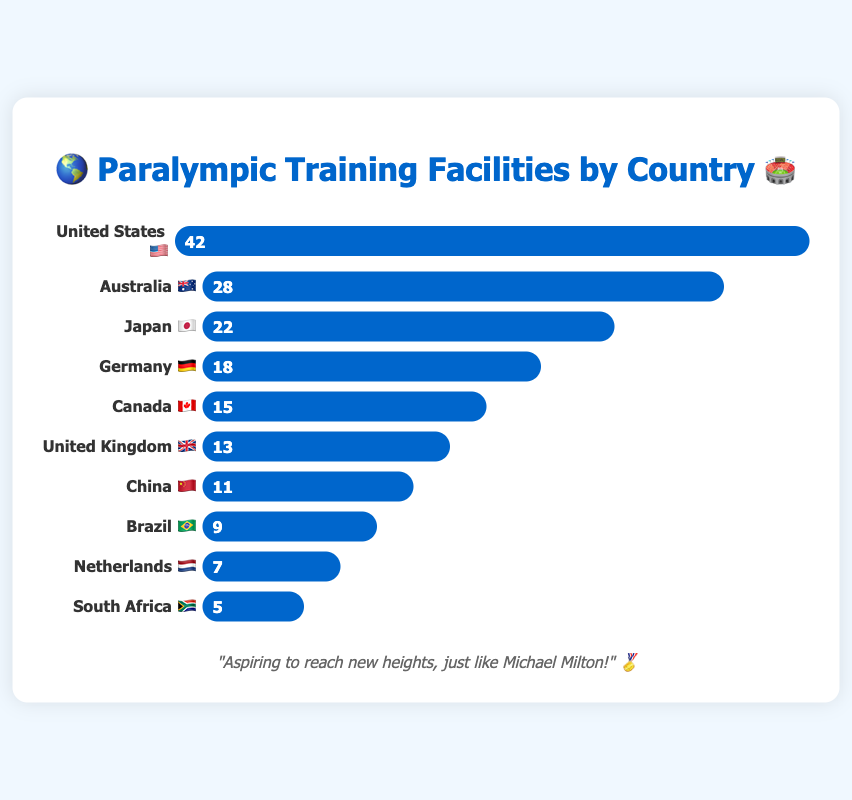What's the title of the chart? The chart title is at the top and is highlighted in blue. It reads "🌎 Paralympic Training Facilities by Country 🏟️".
Answer: 🌎 Paralympic Training Facilities by Country 🏟️ Which country has the highest number of Paralympic training facilities? The longest bar in the chart indicates the country with the most facilities. The United States 🇺🇸 has the longest bar representing 42 facilities.
Answer: United States 🇺🇸 How many facilities does Australia 🇦🇺 have? The chart shows each country with its corresponding number of facilities. Australia's bar indicates it has 28 facilities.
Answer: 28 What is the total number of Paralympic training facilities in Germany 🇩🇪 and Japan 🇯🇵 combined? Add the number of facilities in Germany (18) to those in Japan (22). This sum is 18 + 22 = 40.
Answer: 40 Which country has fewer Paralympic training facilities: Canada 🇨🇦 or the United Kingdom 🇬🇧? Compare the bars for Canada and the United Kingdom. Canada has 15 facilities, while the United Kingdom has 13. Therefore, the United Kingdom has fewer facilities.
Answer: United Kingdom 🇬🇧 What is the average number of facilities among all listed countries? There are 10 countries listed. Sum all their facilities (42 + 28 + 22 + 18 + 15 + 13 + 11 + 9 + 7 + 5 = 170) and divide this by 10. The average is 170 / 10 = 17.
Answer: 17 How many more facilities does the United States 🇺🇸 have compared to China 🇨🇳? Subtract the number of facilities in China (11) from those in the United States (42). The difference is 42 - 11 = 31.
Answer: 31 Which country has the smallest bar representing its number of facilities? The smallest bar will correspond to the country with the fewest facilities. South Africa 🇿🇦, with 5 facilities, has the smallest bar.
Answer: South Africa 🇿🇦 List the countries with more than 20 facilities. From the chart, identify the countries with more than 20 facilities. These countries are the United States 🇺🇸 (42), Australia 🇦🇺 (28), and Japan 🇯🇵 (22).
Answer: United States 🇺🇸, Australia 🇦🇺, Japan 🇯🇵 If a new facility is added to each country, what will be the new total number of facilities? First, add 1 to each country’s facilities and then sum them. 43 + 29 + 23 + 19 + 16 + 14 + 12 + 10 + 8 + 6 = 180.
Answer: 180 